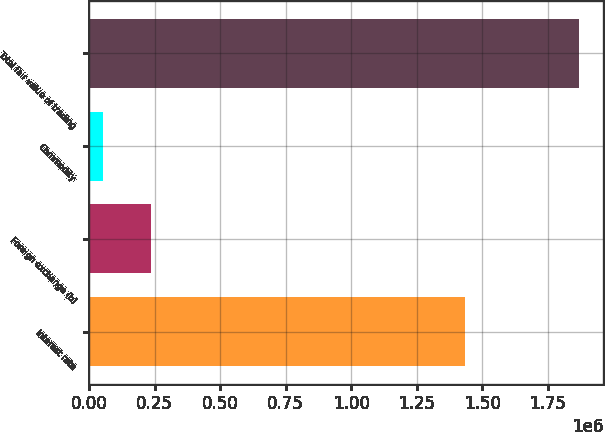<chart> <loc_0><loc_0><loc_500><loc_500><bar_chart><fcel>Interest rate<fcel>Foreign exchange (b)<fcel>Commodity<fcel>Total fair value of trading<nl><fcel>1.4339e+06<fcel>235372<fcel>53894<fcel>1.86868e+06<nl></chart> 